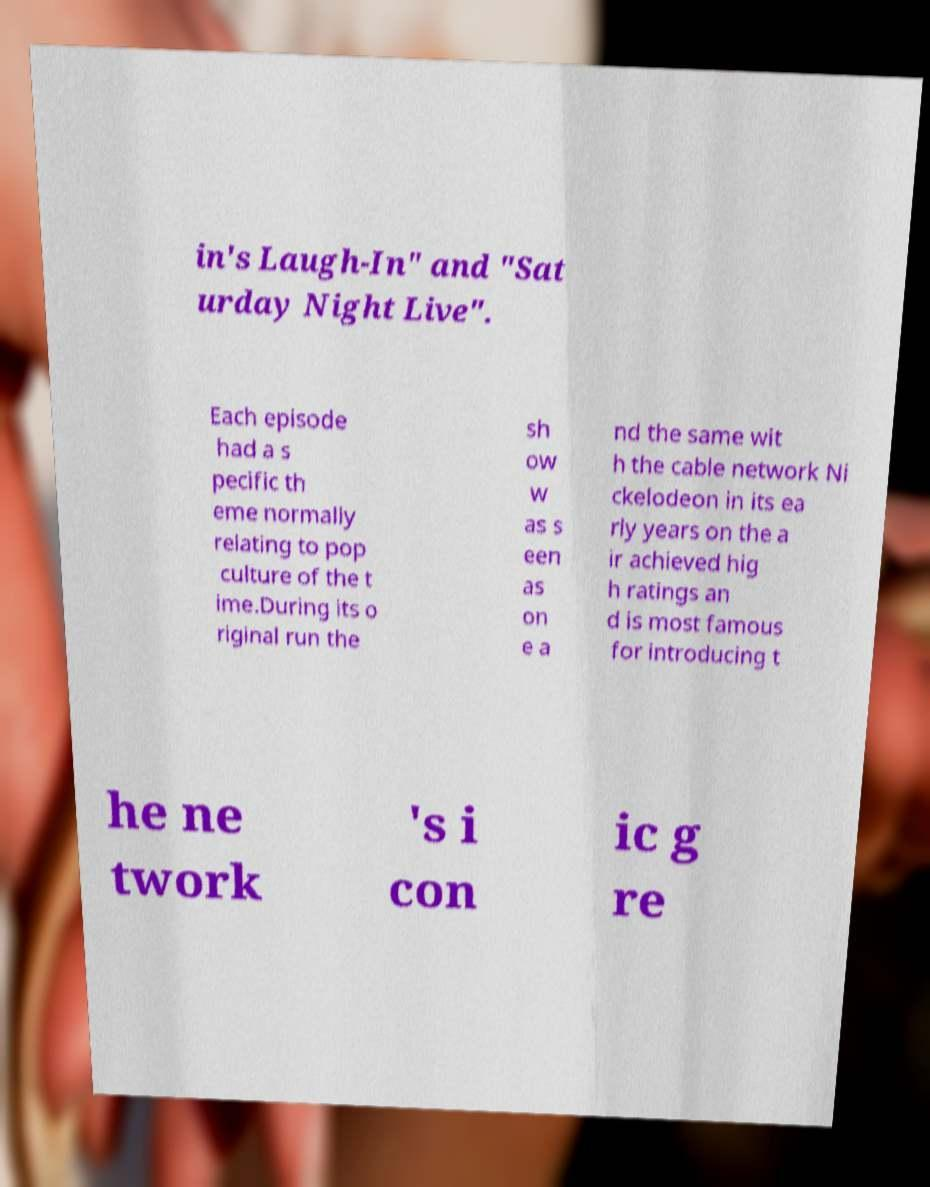Can you read and provide the text displayed in the image?This photo seems to have some interesting text. Can you extract and type it out for me? in's Laugh-In" and "Sat urday Night Live". Each episode had a s pecific th eme normally relating to pop culture of the t ime.During its o riginal run the sh ow w as s een as on e a nd the same wit h the cable network Ni ckelodeon in its ea rly years on the a ir achieved hig h ratings an d is most famous for introducing t he ne twork 's i con ic g re 